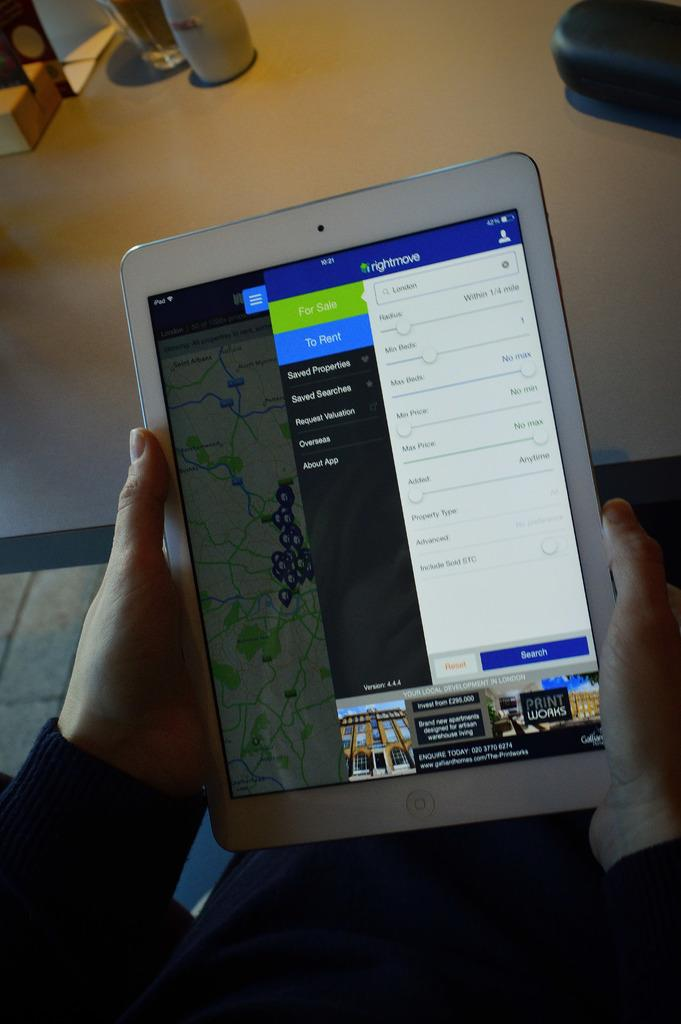What is the person holding in the image? The person is holding a tab in the image. What is on the table in the image? There is a glass and other objects on the table in the image. What can be seen on the screen of the tab? There is text visible on the screen of the tab. Can you see any apples floating in the river in the image? There is no river or apples present in the image. 